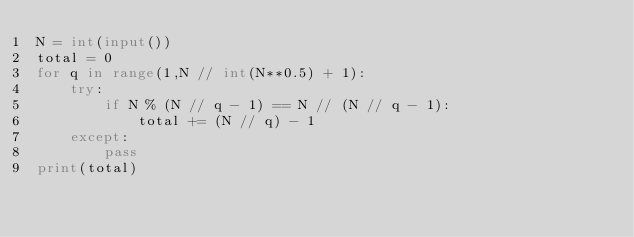Convert code to text. <code><loc_0><loc_0><loc_500><loc_500><_Python_>N = int(input())
total = 0
for q in range(1,N // int(N**0.5) + 1):
	try:
		if N % (N // q - 1) == N // (N // q - 1):
			total += (N // q) - 1
	except:
		pass
print(total)</code> 